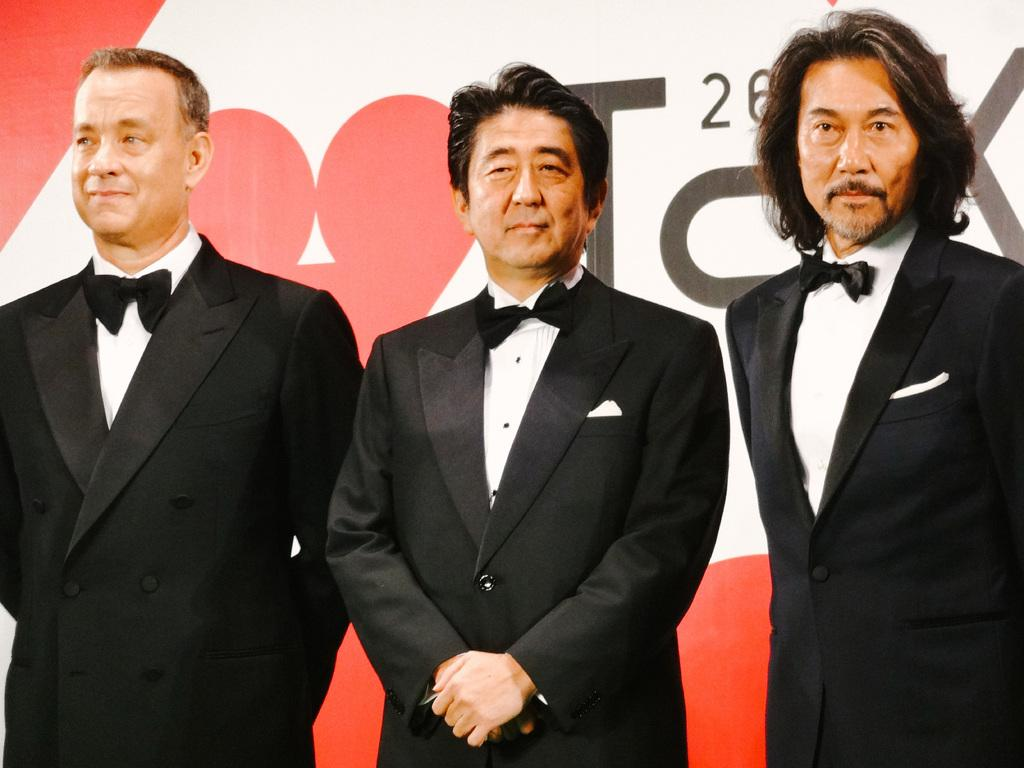What is the main subject of the image? The main subject of the image is men standing. Where are the men standing in the image? The men are standing on the floor. What can be seen in the background of the image? There is an advertisement in the background of the image. What type of picture is being discussed during the meeting in the image? There is no meeting or picture present in the image; it only features men standing on the floor with an advertisement in the background. 